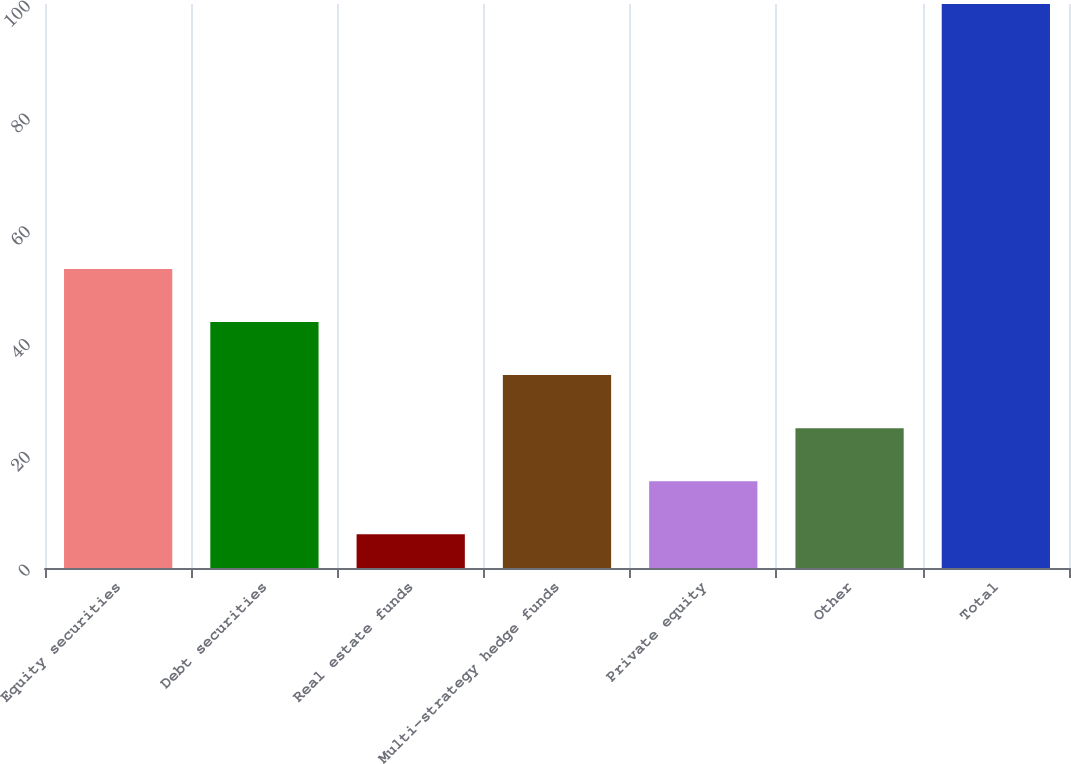<chart> <loc_0><loc_0><loc_500><loc_500><bar_chart><fcel>Equity securities<fcel>Debt securities<fcel>Real estate funds<fcel>Multi-strategy hedge funds<fcel>Private equity<fcel>Other<fcel>Total<nl><fcel>53<fcel>43.6<fcel>6<fcel>34.2<fcel>15.4<fcel>24.8<fcel>100<nl></chart> 